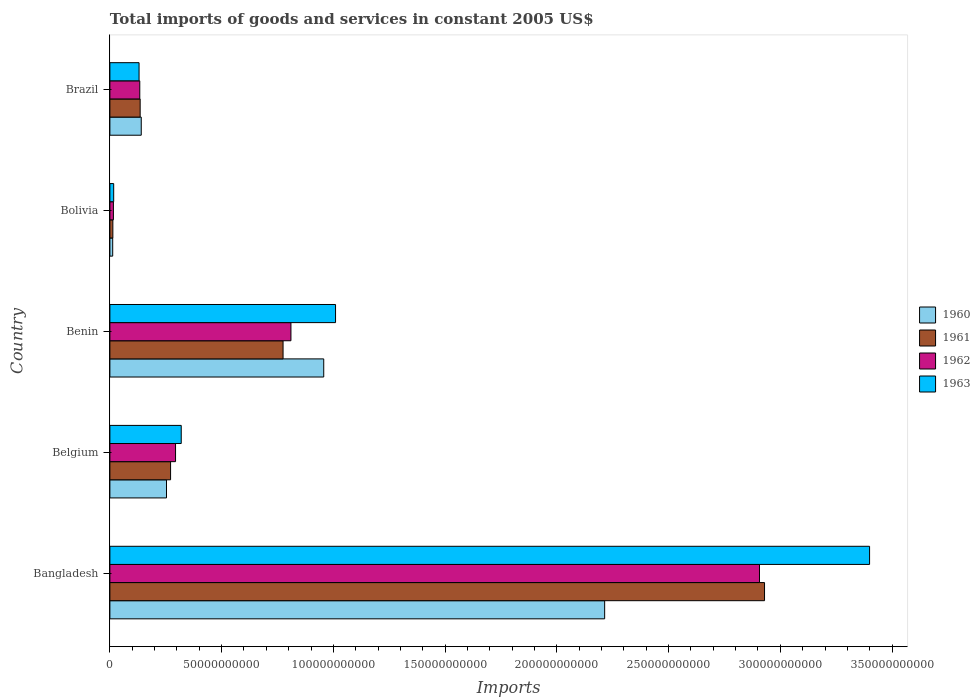How many different coloured bars are there?
Your answer should be very brief. 4. How many groups of bars are there?
Offer a very short reply. 5. Are the number of bars per tick equal to the number of legend labels?
Give a very brief answer. Yes. What is the total imports of goods and services in 1963 in Benin?
Offer a terse response. 1.01e+11. Across all countries, what is the maximum total imports of goods and services in 1963?
Your answer should be very brief. 3.40e+11. Across all countries, what is the minimum total imports of goods and services in 1963?
Make the answer very short. 1.70e+09. In which country was the total imports of goods and services in 1963 maximum?
Offer a very short reply. Bangladesh. What is the total total imports of goods and services in 1960 in the graph?
Offer a terse response. 3.58e+11. What is the difference between the total imports of goods and services in 1961 in Bangladesh and that in Belgium?
Make the answer very short. 2.66e+11. What is the difference between the total imports of goods and services in 1960 in Brazil and the total imports of goods and services in 1962 in Benin?
Your answer should be compact. -6.70e+1. What is the average total imports of goods and services in 1960 per country?
Your answer should be compact. 7.15e+1. What is the difference between the total imports of goods and services in 1961 and total imports of goods and services in 1962 in Benin?
Offer a very short reply. -3.52e+09. What is the ratio of the total imports of goods and services in 1962 in Bolivia to that in Brazil?
Your answer should be very brief. 0.12. Is the total imports of goods and services in 1963 in Bangladesh less than that in Belgium?
Ensure brevity in your answer.  No. What is the difference between the highest and the second highest total imports of goods and services in 1960?
Your answer should be compact. 1.26e+11. What is the difference between the highest and the lowest total imports of goods and services in 1962?
Give a very brief answer. 2.89e+11. In how many countries, is the total imports of goods and services in 1961 greater than the average total imports of goods and services in 1961 taken over all countries?
Offer a terse response. 1. What does the 1st bar from the bottom in Brazil represents?
Provide a short and direct response. 1960. Is it the case that in every country, the sum of the total imports of goods and services in 1963 and total imports of goods and services in 1962 is greater than the total imports of goods and services in 1961?
Your answer should be very brief. Yes. How many bars are there?
Give a very brief answer. 20. Are all the bars in the graph horizontal?
Keep it short and to the point. Yes. What is the difference between two consecutive major ticks on the X-axis?
Keep it short and to the point. 5.00e+1. Where does the legend appear in the graph?
Your answer should be very brief. Center right. How are the legend labels stacked?
Your answer should be compact. Vertical. What is the title of the graph?
Your response must be concise. Total imports of goods and services in constant 2005 US$. What is the label or title of the X-axis?
Your answer should be very brief. Imports. What is the Imports of 1960 in Bangladesh?
Keep it short and to the point. 2.21e+11. What is the Imports of 1961 in Bangladesh?
Offer a terse response. 2.93e+11. What is the Imports in 1962 in Bangladesh?
Make the answer very short. 2.91e+11. What is the Imports in 1963 in Bangladesh?
Make the answer very short. 3.40e+11. What is the Imports of 1960 in Belgium?
Your answer should be very brief. 2.53e+1. What is the Imports of 1961 in Belgium?
Give a very brief answer. 2.72e+1. What is the Imports of 1962 in Belgium?
Your answer should be very brief. 2.94e+1. What is the Imports of 1963 in Belgium?
Keep it short and to the point. 3.19e+1. What is the Imports of 1960 in Benin?
Your answer should be very brief. 9.57e+1. What is the Imports of 1961 in Benin?
Make the answer very short. 7.75e+1. What is the Imports in 1962 in Benin?
Offer a very short reply. 8.10e+1. What is the Imports of 1963 in Benin?
Ensure brevity in your answer.  1.01e+11. What is the Imports of 1960 in Bolivia?
Provide a succinct answer. 1.26e+09. What is the Imports of 1961 in Bolivia?
Keep it short and to the point. 1.33e+09. What is the Imports of 1962 in Bolivia?
Keep it short and to the point. 1.58e+09. What is the Imports of 1963 in Bolivia?
Offer a very short reply. 1.70e+09. What is the Imports in 1960 in Brazil?
Your answer should be very brief. 1.40e+1. What is the Imports in 1961 in Brazil?
Your answer should be compact. 1.35e+1. What is the Imports of 1962 in Brazil?
Offer a very short reply. 1.34e+1. What is the Imports of 1963 in Brazil?
Provide a short and direct response. 1.31e+1. Across all countries, what is the maximum Imports of 1960?
Provide a succinct answer. 2.21e+11. Across all countries, what is the maximum Imports of 1961?
Make the answer very short. 2.93e+11. Across all countries, what is the maximum Imports in 1962?
Offer a very short reply. 2.91e+11. Across all countries, what is the maximum Imports of 1963?
Your answer should be very brief. 3.40e+11. Across all countries, what is the minimum Imports in 1960?
Your answer should be very brief. 1.26e+09. Across all countries, what is the minimum Imports of 1961?
Offer a terse response. 1.33e+09. Across all countries, what is the minimum Imports in 1962?
Make the answer very short. 1.58e+09. Across all countries, what is the minimum Imports in 1963?
Provide a succinct answer. 1.70e+09. What is the total Imports of 1960 in the graph?
Make the answer very short. 3.58e+11. What is the total Imports of 1961 in the graph?
Your answer should be very brief. 4.12e+11. What is the total Imports in 1962 in the graph?
Offer a very short reply. 4.16e+11. What is the total Imports of 1963 in the graph?
Offer a terse response. 4.88e+11. What is the difference between the Imports of 1960 in Bangladesh and that in Belgium?
Offer a terse response. 1.96e+11. What is the difference between the Imports in 1961 in Bangladesh and that in Belgium?
Your response must be concise. 2.66e+11. What is the difference between the Imports in 1962 in Bangladesh and that in Belgium?
Keep it short and to the point. 2.61e+11. What is the difference between the Imports in 1963 in Bangladesh and that in Belgium?
Offer a terse response. 3.08e+11. What is the difference between the Imports in 1960 in Bangladesh and that in Benin?
Your answer should be compact. 1.26e+11. What is the difference between the Imports in 1961 in Bangladesh and that in Benin?
Your answer should be compact. 2.15e+11. What is the difference between the Imports of 1962 in Bangladesh and that in Benin?
Your response must be concise. 2.10e+11. What is the difference between the Imports in 1963 in Bangladesh and that in Benin?
Ensure brevity in your answer.  2.39e+11. What is the difference between the Imports in 1960 in Bangladesh and that in Bolivia?
Provide a succinct answer. 2.20e+11. What is the difference between the Imports of 1961 in Bangladesh and that in Bolivia?
Your answer should be very brief. 2.92e+11. What is the difference between the Imports in 1962 in Bangladesh and that in Bolivia?
Keep it short and to the point. 2.89e+11. What is the difference between the Imports of 1963 in Bangladesh and that in Bolivia?
Provide a short and direct response. 3.38e+11. What is the difference between the Imports of 1960 in Bangladesh and that in Brazil?
Your answer should be compact. 2.07e+11. What is the difference between the Imports of 1961 in Bangladesh and that in Brazil?
Ensure brevity in your answer.  2.79e+11. What is the difference between the Imports in 1962 in Bangladesh and that in Brazil?
Your response must be concise. 2.77e+11. What is the difference between the Imports of 1963 in Bangladesh and that in Brazil?
Your answer should be compact. 3.27e+11. What is the difference between the Imports of 1960 in Belgium and that in Benin?
Offer a very short reply. -7.04e+1. What is the difference between the Imports of 1961 in Belgium and that in Benin?
Provide a succinct answer. -5.03e+1. What is the difference between the Imports in 1962 in Belgium and that in Benin?
Your answer should be compact. -5.16e+1. What is the difference between the Imports in 1963 in Belgium and that in Benin?
Offer a very short reply. -6.90e+1. What is the difference between the Imports in 1960 in Belgium and that in Bolivia?
Offer a very short reply. 2.41e+1. What is the difference between the Imports in 1961 in Belgium and that in Bolivia?
Your answer should be compact. 2.58e+1. What is the difference between the Imports of 1962 in Belgium and that in Bolivia?
Give a very brief answer. 2.78e+1. What is the difference between the Imports in 1963 in Belgium and that in Bolivia?
Your answer should be compact. 3.02e+1. What is the difference between the Imports of 1960 in Belgium and that in Brazil?
Make the answer very short. 1.13e+1. What is the difference between the Imports of 1961 in Belgium and that in Brazil?
Your answer should be compact. 1.36e+1. What is the difference between the Imports of 1962 in Belgium and that in Brazil?
Give a very brief answer. 1.60e+1. What is the difference between the Imports in 1963 in Belgium and that in Brazil?
Offer a terse response. 1.89e+1. What is the difference between the Imports of 1960 in Benin and that in Bolivia?
Your response must be concise. 9.44e+1. What is the difference between the Imports in 1961 in Benin and that in Bolivia?
Give a very brief answer. 7.62e+1. What is the difference between the Imports of 1962 in Benin and that in Bolivia?
Offer a terse response. 7.94e+1. What is the difference between the Imports of 1963 in Benin and that in Bolivia?
Give a very brief answer. 9.93e+1. What is the difference between the Imports in 1960 in Benin and that in Brazil?
Ensure brevity in your answer.  8.17e+1. What is the difference between the Imports of 1961 in Benin and that in Brazil?
Your answer should be compact. 6.39e+1. What is the difference between the Imports of 1962 in Benin and that in Brazil?
Provide a short and direct response. 6.76e+1. What is the difference between the Imports in 1963 in Benin and that in Brazil?
Your answer should be compact. 8.79e+1. What is the difference between the Imports of 1960 in Bolivia and that in Brazil?
Keep it short and to the point. -1.28e+1. What is the difference between the Imports in 1961 in Bolivia and that in Brazil?
Make the answer very short. -1.22e+1. What is the difference between the Imports in 1962 in Bolivia and that in Brazil?
Your answer should be compact. -1.18e+1. What is the difference between the Imports in 1963 in Bolivia and that in Brazil?
Provide a short and direct response. -1.14e+1. What is the difference between the Imports in 1960 in Bangladesh and the Imports in 1961 in Belgium?
Ensure brevity in your answer.  1.94e+11. What is the difference between the Imports in 1960 in Bangladesh and the Imports in 1962 in Belgium?
Your answer should be very brief. 1.92e+11. What is the difference between the Imports of 1960 in Bangladesh and the Imports of 1963 in Belgium?
Your answer should be very brief. 1.89e+11. What is the difference between the Imports of 1961 in Bangladesh and the Imports of 1962 in Belgium?
Offer a very short reply. 2.64e+11. What is the difference between the Imports of 1961 in Bangladesh and the Imports of 1963 in Belgium?
Your answer should be very brief. 2.61e+11. What is the difference between the Imports of 1962 in Bangladesh and the Imports of 1963 in Belgium?
Your answer should be very brief. 2.59e+11. What is the difference between the Imports of 1960 in Bangladesh and the Imports of 1961 in Benin?
Your answer should be very brief. 1.44e+11. What is the difference between the Imports of 1960 in Bangladesh and the Imports of 1962 in Benin?
Provide a succinct answer. 1.40e+11. What is the difference between the Imports of 1960 in Bangladesh and the Imports of 1963 in Benin?
Ensure brevity in your answer.  1.20e+11. What is the difference between the Imports of 1961 in Bangladesh and the Imports of 1962 in Benin?
Ensure brevity in your answer.  2.12e+11. What is the difference between the Imports of 1961 in Bangladesh and the Imports of 1963 in Benin?
Keep it short and to the point. 1.92e+11. What is the difference between the Imports in 1962 in Bangladesh and the Imports in 1963 in Benin?
Offer a terse response. 1.90e+11. What is the difference between the Imports in 1960 in Bangladesh and the Imports in 1961 in Bolivia?
Your response must be concise. 2.20e+11. What is the difference between the Imports of 1960 in Bangladesh and the Imports of 1962 in Bolivia?
Keep it short and to the point. 2.20e+11. What is the difference between the Imports in 1960 in Bangladesh and the Imports in 1963 in Bolivia?
Keep it short and to the point. 2.20e+11. What is the difference between the Imports in 1961 in Bangladesh and the Imports in 1962 in Bolivia?
Offer a terse response. 2.91e+11. What is the difference between the Imports in 1961 in Bangladesh and the Imports in 1963 in Bolivia?
Your answer should be very brief. 2.91e+11. What is the difference between the Imports in 1962 in Bangladesh and the Imports in 1963 in Bolivia?
Your answer should be compact. 2.89e+11. What is the difference between the Imports of 1960 in Bangladesh and the Imports of 1961 in Brazil?
Your answer should be compact. 2.08e+11. What is the difference between the Imports in 1960 in Bangladesh and the Imports in 1962 in Brazil?
Your answer should be compact. 2.08e+11. What is the difference between the Imports in 1960 in Bangladesh and the Imports in 1963 in Brazil?
Your response must be concise. 2.08e+11. What is the difference between the Imports in 1961 in Bangladesh and the Imports in 1962 in Brazil?
Your response must be concise. 2.80e+11. What is the difference between the Imports in 1961 in Bangladesh and the Imports in 1963 in Brazil?
Give a very brief answer. 2.80e+11. What is the difference between the Imports in 1962 in Bangladesh and the Imports in 1963 in Brazil?
Your response must be concise. 2.78e+11. What is the difference between the Imports in 1960 in Belgium and the Imports in 1961 in Benin?
Your answer should be compact. -5.22e+1. What is the difference between the Imports in 1960 in Belgium and the Imports in 1962 in Benin?
Keep it short and to the point. -5.57e+1. What is the difference between the Imports in 1960 in Belgium and the Imports in 1963 in Benin?
Keep it short and to the point. -7.56e+1. What is the difference between the Imports of 1961 in Belgium and the Imports of 1962 in Benin?
Your response must be concise. -5.39e+1. What is the difference between the Imports of 1961 in Belgium and the Imports of 1963 in Benin?
Your answer should be very brief. -7.38e+1. What is the difference between the Imports in 1962 in Belgium and the Imports in 1963 in Benin?
Ensure brevity in your answer.  -7.16e+1. What is the difference between the Imports in 1960 in Belgium and the Imports in 1961 in Bolivia?
Keep it short and to the point. 2.40e+1. What is the difference between the Imports of 1960 in Belgium and the Imports of 1962 in Bolivia?
Make the answer very short. 2.38e+1. What is the difference between the Imports in 1960 in Belgium and the Imports in 1963 in Bolivia?
Make the answer very short. 2.36e+1. What is the difference between the Imports of 1961 in Belgium and the Imports of 1962 in Bolivia?
Offer a terse response. 2.56e+1. What is the difference between the Imports in 1961 in Belgium and the Imports in 1963 in Bolivia?
Make the answer very short. 2.55e+1. What is the difference between the Imports in 1962 in Belgium and the Imports in 1963 in Bolivia?
Provide a short and direct response. 2.77e+1. What is the difference between the Imports in 1960 in Belgium and the Imports in 1961 in Brazil?
Your answer should be compact. 1.18e+1. What is the difference between the Imports in 1960 in Belgium and the Imports in 1962 in Brazil?
Your answer should be very brief. 1.20e+1. What is the difference between the Imports of 1960 in Belgium and the Imports of 1963 in Brazil?
Make the answer very short. 1.23e+1. What is the difference between the Imports of 1961 in Belgium and the Imports of 1962 in Brazil?
Provide a short and direct response. 1.38e+1. What is the difference between the Imports of 1961 in Belgium and the Imports of 1963 in Brazil?
Your answer should be very brief. 1.41e+1. What is the difference between the Imports of 1962 in Belgium and the Imports of 1963 in Brazil?
Give a very brief answer. 1.63e+1. What is the difference between the Imports of 1960 in Benin and the Imports of 1961 in Bolivia?
Offer a terse response. 9.44e+1. What is the difference between the Imports of 1960 in Benin and the Imports of 1962 in Bolivia?
Make the answer very short. 9.41e+1. What is the difference between the Imports in 1960 in Benin and the Imports in 1963 in Bolivia?
Provide a short and direct response. 9.40e+1. What is the difference between the Imports of 1961 in Benin and the Imports of 1962 in Bolivia?
Your answer should be very brief. 7.59e+1. What is the difference between the Imports in 1961 in Benin and the Imports in 1963 in Bolivia?
Offer a very short reply. 7.58e+1. What is the difference between the Imports in 1962 in Benin and the Imports in 1963 in Bolivia?
Provide a short and direct response. 7.93e+1. What is the difference between the Imports in 1960 in Benin and the Imports in 1961 in Brazil?
Offer a very short reply. 8.21e+1. What is the difference between the Imports in 1960 in Benin and the Imports in 1962 in Brazil?
Give a very brief answer. 8.23e+1. What is the difference between the Imports in 1960 in Benin and the Imports in 1963 in Brazil?
Provide a short and direct response. 8.26e+1. What is the difference between the Imports of 1961 in Benin and the Imports of 1962 in Brazil?
Your response must be concise. 6.41e+1. What is the difference between the Imports of 1961 in Benin and the Imports of 1963 in Brazil?
Offer a terse response. 6.44e+1. What is the difference between the Imports of 1962 in Benin and the Imports of 1963 in Brazil?
Offer a very short reply. 6.80e+1. What is the difference between the Imports in 1960 in Bolivia and the Imports in 1961 in Brazil?
Offer a very short reply. -1.23e+1. What is the difference between the Imports in 1960 in Bolivia and the Imports in 1962 in Brazil?
Your answer should be compact. -1.21e+1. What is the difference between the Imports in 1960 in Bolivia and the Imports in 1963 in Brazil?
Provide a succinct answer. -1.18e+1. What is the difference between the Imports in 1961 in Bolivia and the Imports in 1962 in Brazil?
Your response must be concise. -1.20e+1. What is the difference between the Imports of 1961 in Bolivia and the Imports of 1963 in Brazil?
Your response must be concise. -1.17e+1. What is the difference between the Imports of 1962 in Bolivia and the Imports of 1963 in Brazil?
Ensure brevity in your answer.  -1.15e+1. What is the average Imports of 1960 per country?
Offer a very short reply. 7.15e+1. What is the average Imports of 1961 per country?
Give a very brief answer. 8.25e+1. What is the average Imports in 1962 per country?
Provide a short and direct response. 8.32e+1. What is the average Imports of 1963 per country?
Give a very brief answer. 9.75e+1. What is the difference between the Imports of 1960 and Imports of 1961 in Bangladesh?
Ensure brevity in your answer.  -7.15e+1. What is the difference between the Imports in 1960 and Imports in 1962 in Bangladesh?
Offer a terse response. -6.93e+1. What is the difference between the Imports of 1960 and Imports of 1963 in Bangladesh?
Your response must be concise. -1.19e+11. What is the difference between the Imports of 1961 and Imports of 1962 in Bangladesh?
Provide a succinct answer. 2.26e+09. What is the difference between the Imports in 1961 and Imports in 1963 in Bangladesh?
Your answer should be compact. -4.70e+1. What is the difference between the Imports of 1962 and Imports of 1963 in Bangladesh?
Keep it short and to the point. -4.93e+1. What is the difference between the Imports in 1960 and Imports in 1961 in Belgium?
Ensure brevity in your answer.  -1.82e+09. What is the difference between the Imports of 1960 and Imports of 1962 in Belgium?
Offer a terse response. -4.05e+09. What is the difference between the Imports in 1960 and Imports in 1963 in Belgium?
Your answer should be compact. -6.59e+09. What is the difference between the Imports in 1961 and Imports in 1962 in Belgium?
Make the answer very short. -2.23e+09. What is the difference between the Imports of 1961 and Imports of 1963 in Belgium?
Provide a succinct answer. -4.77e+09. What is the difference between the Imports of 1962 and Imports of 1963 in Belgium?
Your response must be concise. -2.54e+09. What is the difference between the Imports in 1960 and Imports in 1961 in Benin?
Provide a short and direct response. 1.82e+1. What is the difference between the Imports in 1960 and Imports in 1962 in Benin?
Provide a succinct answer. 1.47e+1. What is the difference between the Imports of 1960 and Imports of 1963 in Benin?
Offer a very short reply. -5.28e+09. What is the difference between the Imports in 1961 and Imports in 1962 in Benin?
Your answer should be very brief. -3.52e+09. What is the difference between the Imports of 1961 and Imports of 1963 in Benin?
Make the answer very short. -2.35e+1. What is the difference between the Imports of 1962 and Imports of 1963 in Benin?
Your response must be concise. -2.00e+1. What is the difference between the Imports of 1960 and Imports of 1961 in Bolivia?
Ensure brevity in your answer.  -7.36e+07. What is the difference between the Imports in 1960 and Imports in 1962 in Bolivia?
Your answer should be compact. -3.19e+08. What is the difference between the Imports of 1960 and Imports of 1963 in Bolivia?
Make the answer very short. -4.41e+08. What is the difference between the Imports of 1961 and Imports of 1962 in Bolivia?
Your answer should be very brief. -2.45e+08. What is the difference between the Imports of 1961 and Imports of 1963 in Bolivia?
Give a very brief answer. -3.67e+08. What is the difference between the Imports of 1962 and Imports of 1963 in Bolivia?
Make the answer very short. -1.22e+08. What is the difference between the Imports in 1960 and Imports in 1961 in Brazil?
Your response must be concise. 4.89e+08. What is the difference between the Imports in 1960 and Imports in 1962 in Brazil?
Provide a succinct answer. 6.53e+08. What is the difference between the Imports in 1960 and Imports in 1963 in Brazil?
Offer a very short reply. 9.79e+08. What is the difference between the Imports in 1961 and Imports in 1962 in Brazil?
Provide a succinct answer. 1.63e+08. What is the difference between the Imports in 1961 and Imports in 1963 in Brazil?
Ensure brevity in your answer.  4.89e+08. What is the difference between the Imports in 1962 and Imports in 1963 in Brazil?
Your answer should be very brief. 3.26e+08. What is the ratio of the Imports of 1960 in Bangladesh to that in Belgium?
Make the answer very short. 8.74. What is the ratio of the Imports of 1961 in Bangladesh to that in Belgium?
Provide a short and direct response. 10.79. What is the ratio of the Imports in 1962 in Bangladesh to that in Belgium?
Offer a terse response. 9.89. What is the ratio of the Imports in 1963 in Bangladesh to that in Belgium?
Your answer should be compact. 10.65. What is the ratio of the Imports of 1960 in Bangladesh to that in Benin?
Your response must be concise. 2.31. What is the ratio of the Imports in 1961 in Bangladesh to that in Benin?
Your answer should be compact. 3.78. What is the ratio of the Imports in 1962 in Bangladesh to that in Benin?
Your answer should be compact. 3.59. What is the ratio of the Imports in 1963 in Bangladesh to that in Benin?
Provide a short and direct response. 3.37. What is the ratio of the Imports of 1960 in Bangladesh to that in Bolivia?
Your response must be concise. 176.1. What is the ratio of the Imports in 1961 in Bangladesh to that in Bolivia?
Provide a short and direct response. 220.12. What is the ratio of the Imports of 1962 in Bangladesh to that in Bolivia?
Provide a short and direct response. 184.42. What is the ratio of the Imports of 1963 in Bangladesh to that in Bolivia?
Make the answer very short. 200.23. What is the ratio of the Imports of 1960 in Bangladesh to that in Brazil?
Give a very brief answer. 15.78. What is the ratio of the Imports of 1961 in Bangladesh to that in Brazil?
Offer a terse response. 21.63. What is the ratio of the Imports in 1962 in Bangladesh to that in Brazil?
Provide a short and direct response. 21.73. What is the ratio of the Imports of 1963 in Bangladesh to that in Brazil?
Your response must be concise. 26.04. What is the ratio of the Imports of 1960 in Belgium to that in Benin?
Give a very brief answer. 0.26. What is the ratio of the Imports of 1961 in Belgium to that in Benin?
Offer a terse response. 0.35. What is the ratio of the Imports in 1962 in Belgium to that in Benin?
Provide a short and direct response. 0.36. What is the ratio of the Imports in 1963 in Belgium to that in Benin?
Your response must be concise. 0.32. What is the ratio of the Imports in 1960 in Belgium to that in Bolivia?
Offer a terse response. 20.15. What is the ratio of the Imports in 1961 in Belgium to that in Bolivia?
Your answer should be compact. 20.4. What is the ratio of the Imports of 1962 in Belgium to that in Bolivia?
Give a very brief answer. 18.64. What is the ratio of the Imports of 1963 in Belgium to that in Bolivia?
Your answer should be very brief. 18.8. What is the ratio of the Imports in 1960 in Belgium to that in Brazil?
Provide a short and direct response. 1.81. What is the ratio of the Imports of 1961 in Belgium to that in Brazil?
Give a very brief answer. 2.01. What is the ratio of the Imports in 1962 in Belgium to that in Brazil?
Offer a very short reply. 2.2. What is the ratio of the Imports of 1963 in Belgium to that in Brazil?
Ensure brevity in your answer.  2.45. What is the ratio of the Imports in 1960 in Benin to that in Bolivia?
Give a very brief answer. 76.11. What is the ratio of the Imports of 1961 in Benin to that in Bolivia?
Offer a very short reply. 58.23. What is the ratio of the Imports in 1962 in Benin to that in Bolivia?
Ensure brevity in your answer.  51.4. What is the ratio of the Imports in 1963 in Benin to that in Bolivia?
Offer a very short reply. 59.47. What is the ratio of the Imports of 1960 in Benin to that in Brazil?
Ensure brevity in your answer.  6.82. What is the ratio of the Imports in 1961 in Benin to that in Brazil?
Provide a succinct answer. 5.72. What is the ratio of the Imports of 1962 in Benin to that in Brazil?
Ensure brevity in your answer.  6.06. What is the ratio of the Imports in 1963 in Benin to that in Brazil?
Give a very brief answer. 7.74. What is the ratio of the Imports of 1960 in Bolivia to that in Brazil?
Provide a short and direct response. 0.09. What is the ratio of the Imports in 1961 in Bolivia to that in Brazil?
Make the answer very short. 0.1. What is the ratio of the Imports in 1962 in Bolivia to that in Brazil?
Offer a terse response. 0.12. What is the ratio of the Imports in 1963 in Bolivia to that in Brazil?
Ensure brevity in your answer.  0.13. What is the difference between the highest and the second highest Imports in 1960?
Offer a terse response. 1.26e+11. What is the difference between the highest and the second highest Imports in 1961?
Your response must be concise. 2.15e+11. What is the difference between the highest and the second highest Imports in 1962?
Make the answer very short. 2.10e+11. What is the difference between the highest and the second highest Imports of 1963?
Offer a very short reply. 2.39e+11. What is the difference between the highest and the lowest Imports in 1960?
Your answer should be compact. 2.20e+11. What is the difference between the highest and the lowest Imports in 1961?
Your response must be concise. 2.92e+11. What is the difference between the highest and the lowest Imports of 1962?
Give a very brief answer. 2.89e+11. What is the difference between the highest and the lowest Imports of 1963?
Your response must be concise. 3.38e+11. 